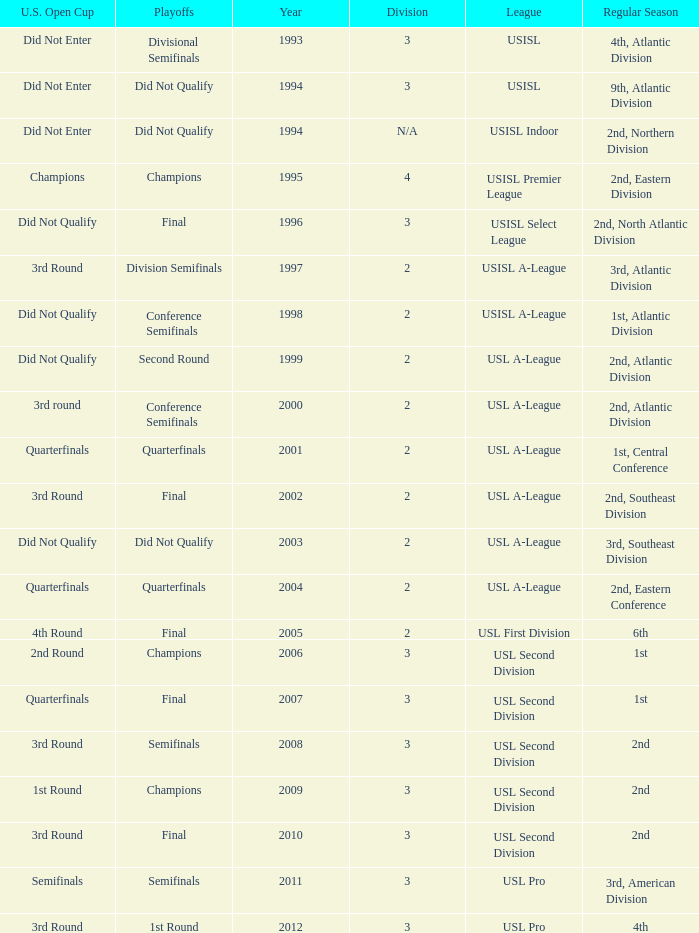How many division  did not qualify for u.s. open cup in 2003 2.0. 